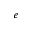<formula> <loc_0><loc_0><loc_500><loc_500>^ { e }</formula> 